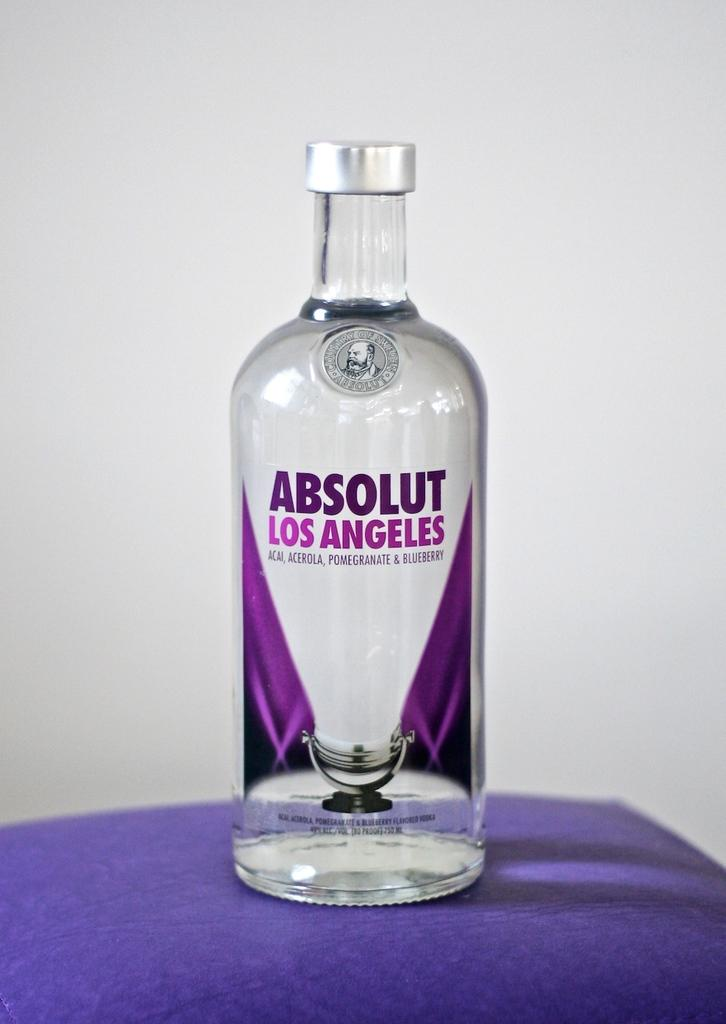What is the main subject in the center of the image? There is a beverage in the center of the image. Where is the beverage placed? The beverage is placed on a table. What can be seen in the background of the image? There is a wall in the background of the image. What type of tin is being used to hold the wool in the image? There is no tin or wool present in the image; it only features a beverage placed on a table with a wall in the background. 